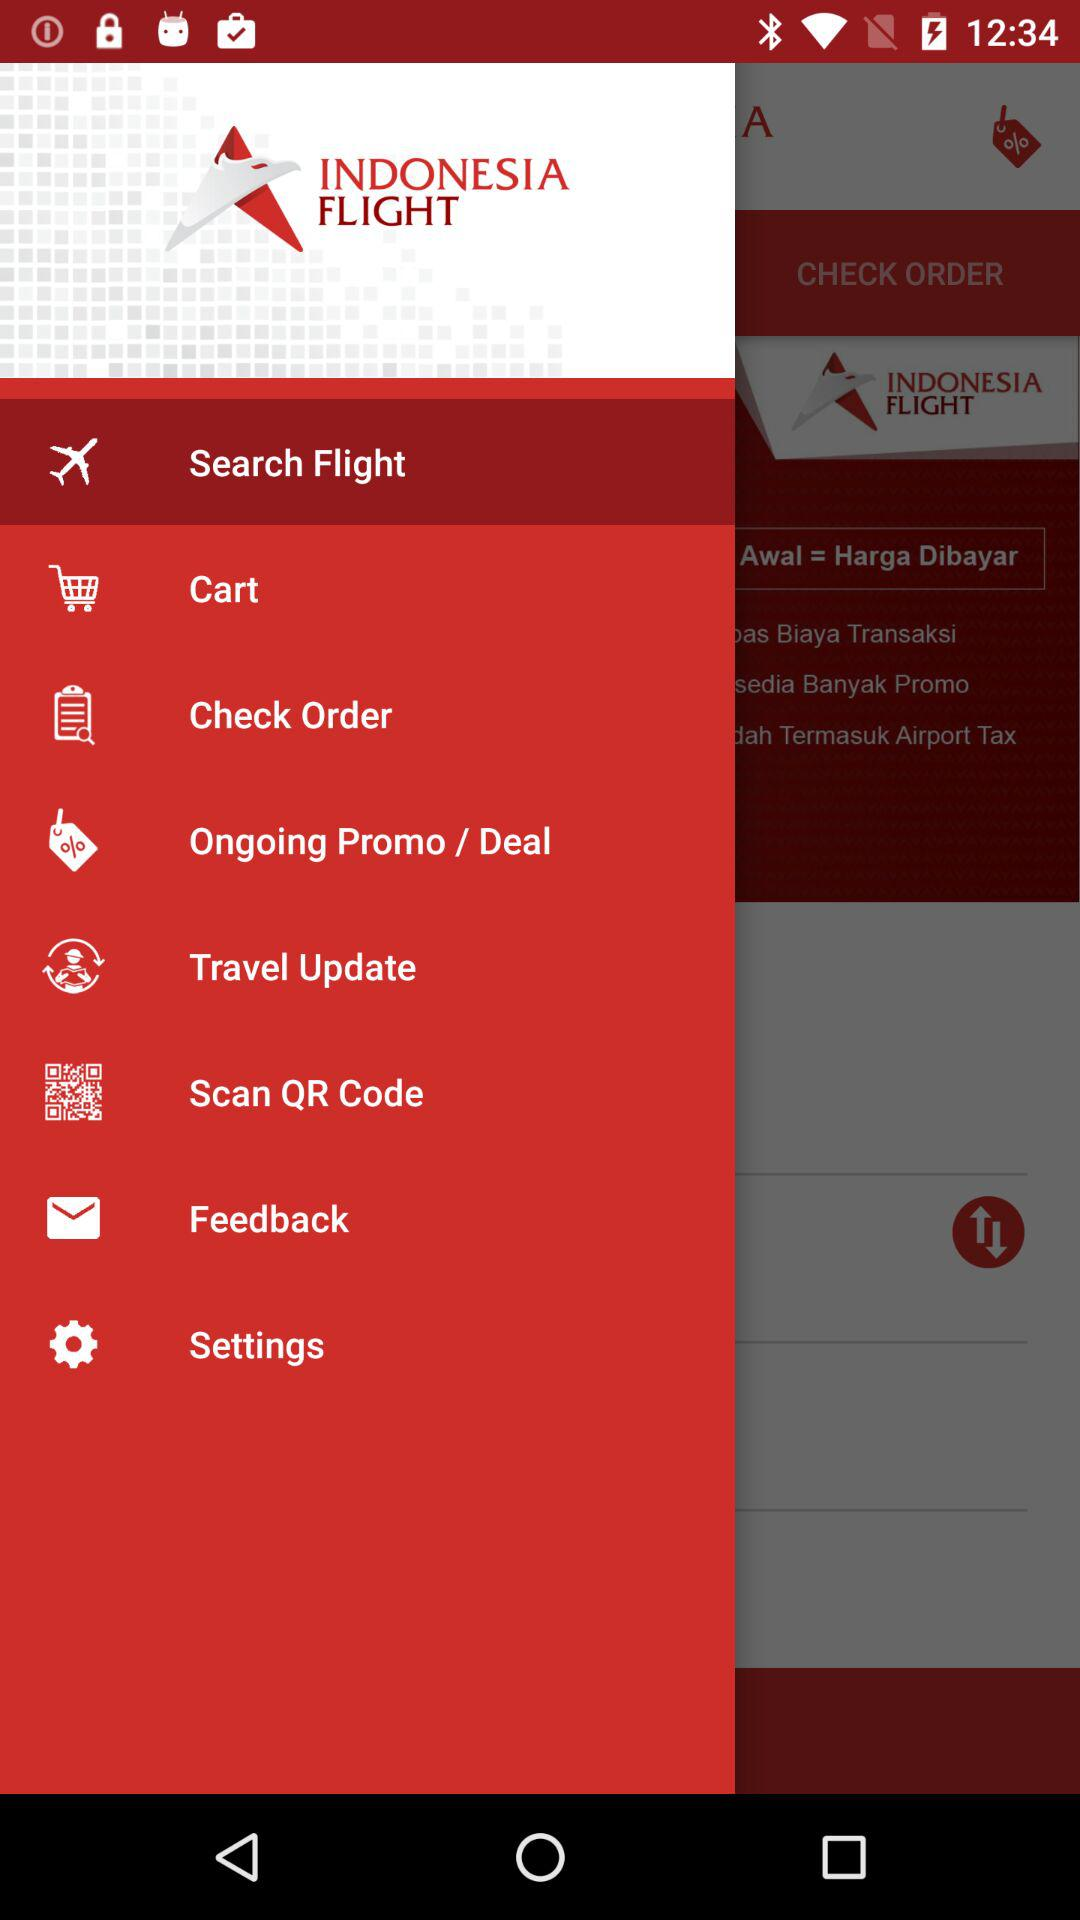How many languages are available in the settings menu?
Answer the question using a single word or phrase. 2 